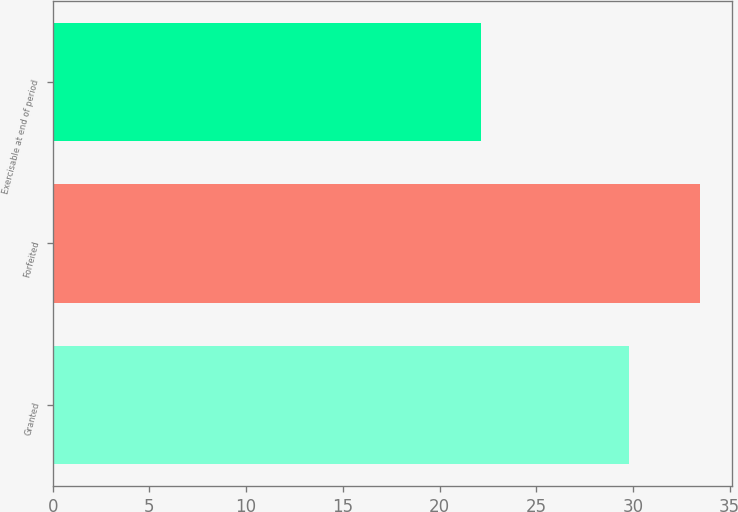Convert chart. <chart><loc_0><loc_0><loc_500><loc_500><bar_chart><fcel>Granted<fcel>Forfeited<fcel>Exercisable at end of period<nl><fcel>29.8<fcel>33.47<fcel>22.13<nl></chart> 